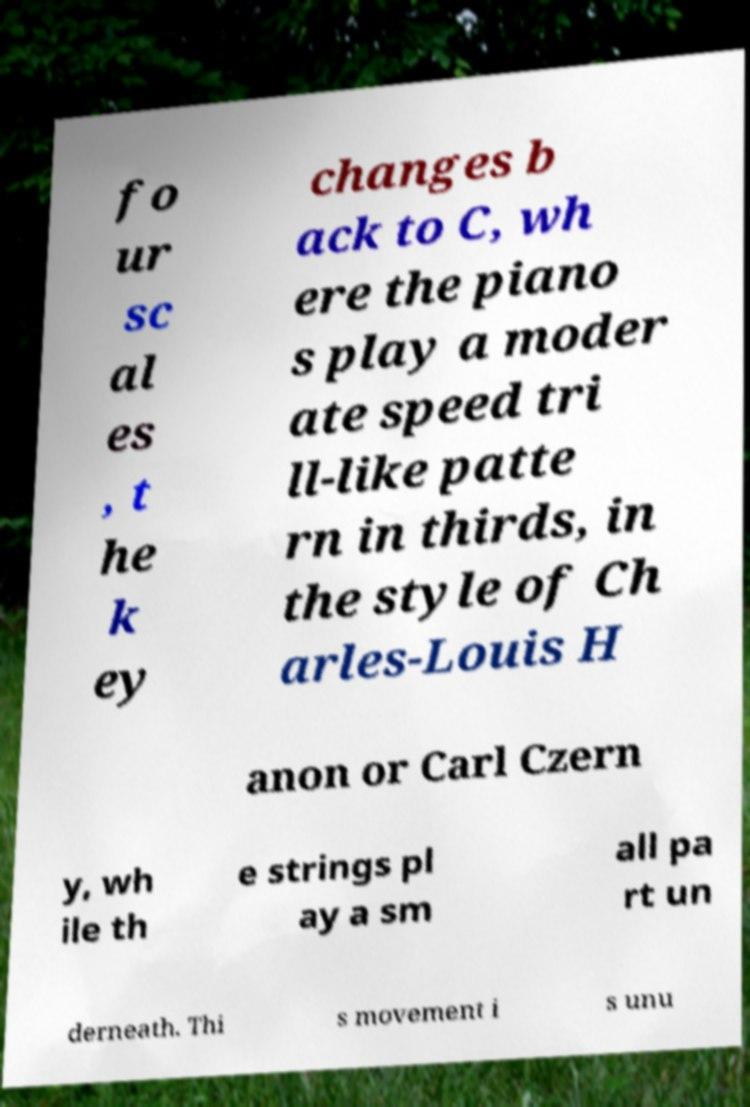For documentation purposes, I need the text within this image transcribed. Could you provide that? fo ur sc al es , t he k ey changes b ack to C, wh ere the piano s play a moder ate speed tri ll-like patte rn in thirds, in the style of Ch arles-Louis H anon or Carl Czern y, wh ile th e strings pl ay a sm all pa rt un derneath. Thi s movement i s unu 